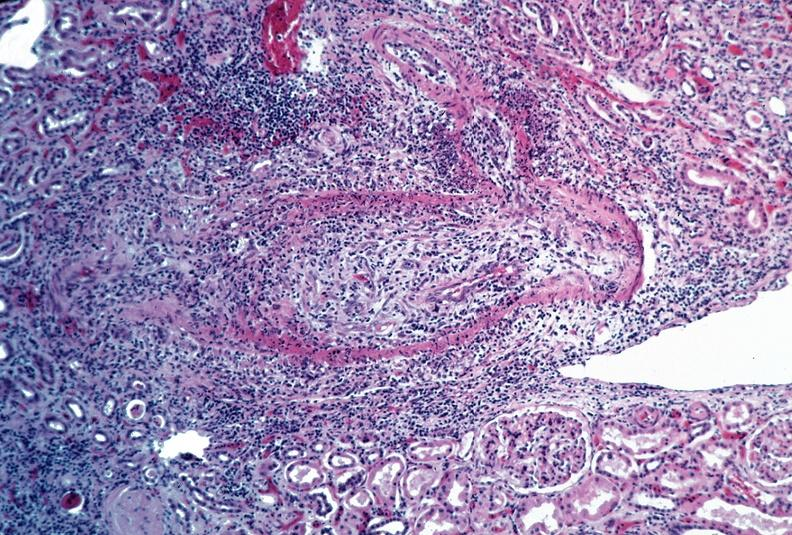does lateral view show vasculitis, polyarteritis nodosa?
Answer the question using a single word or phrase. No 